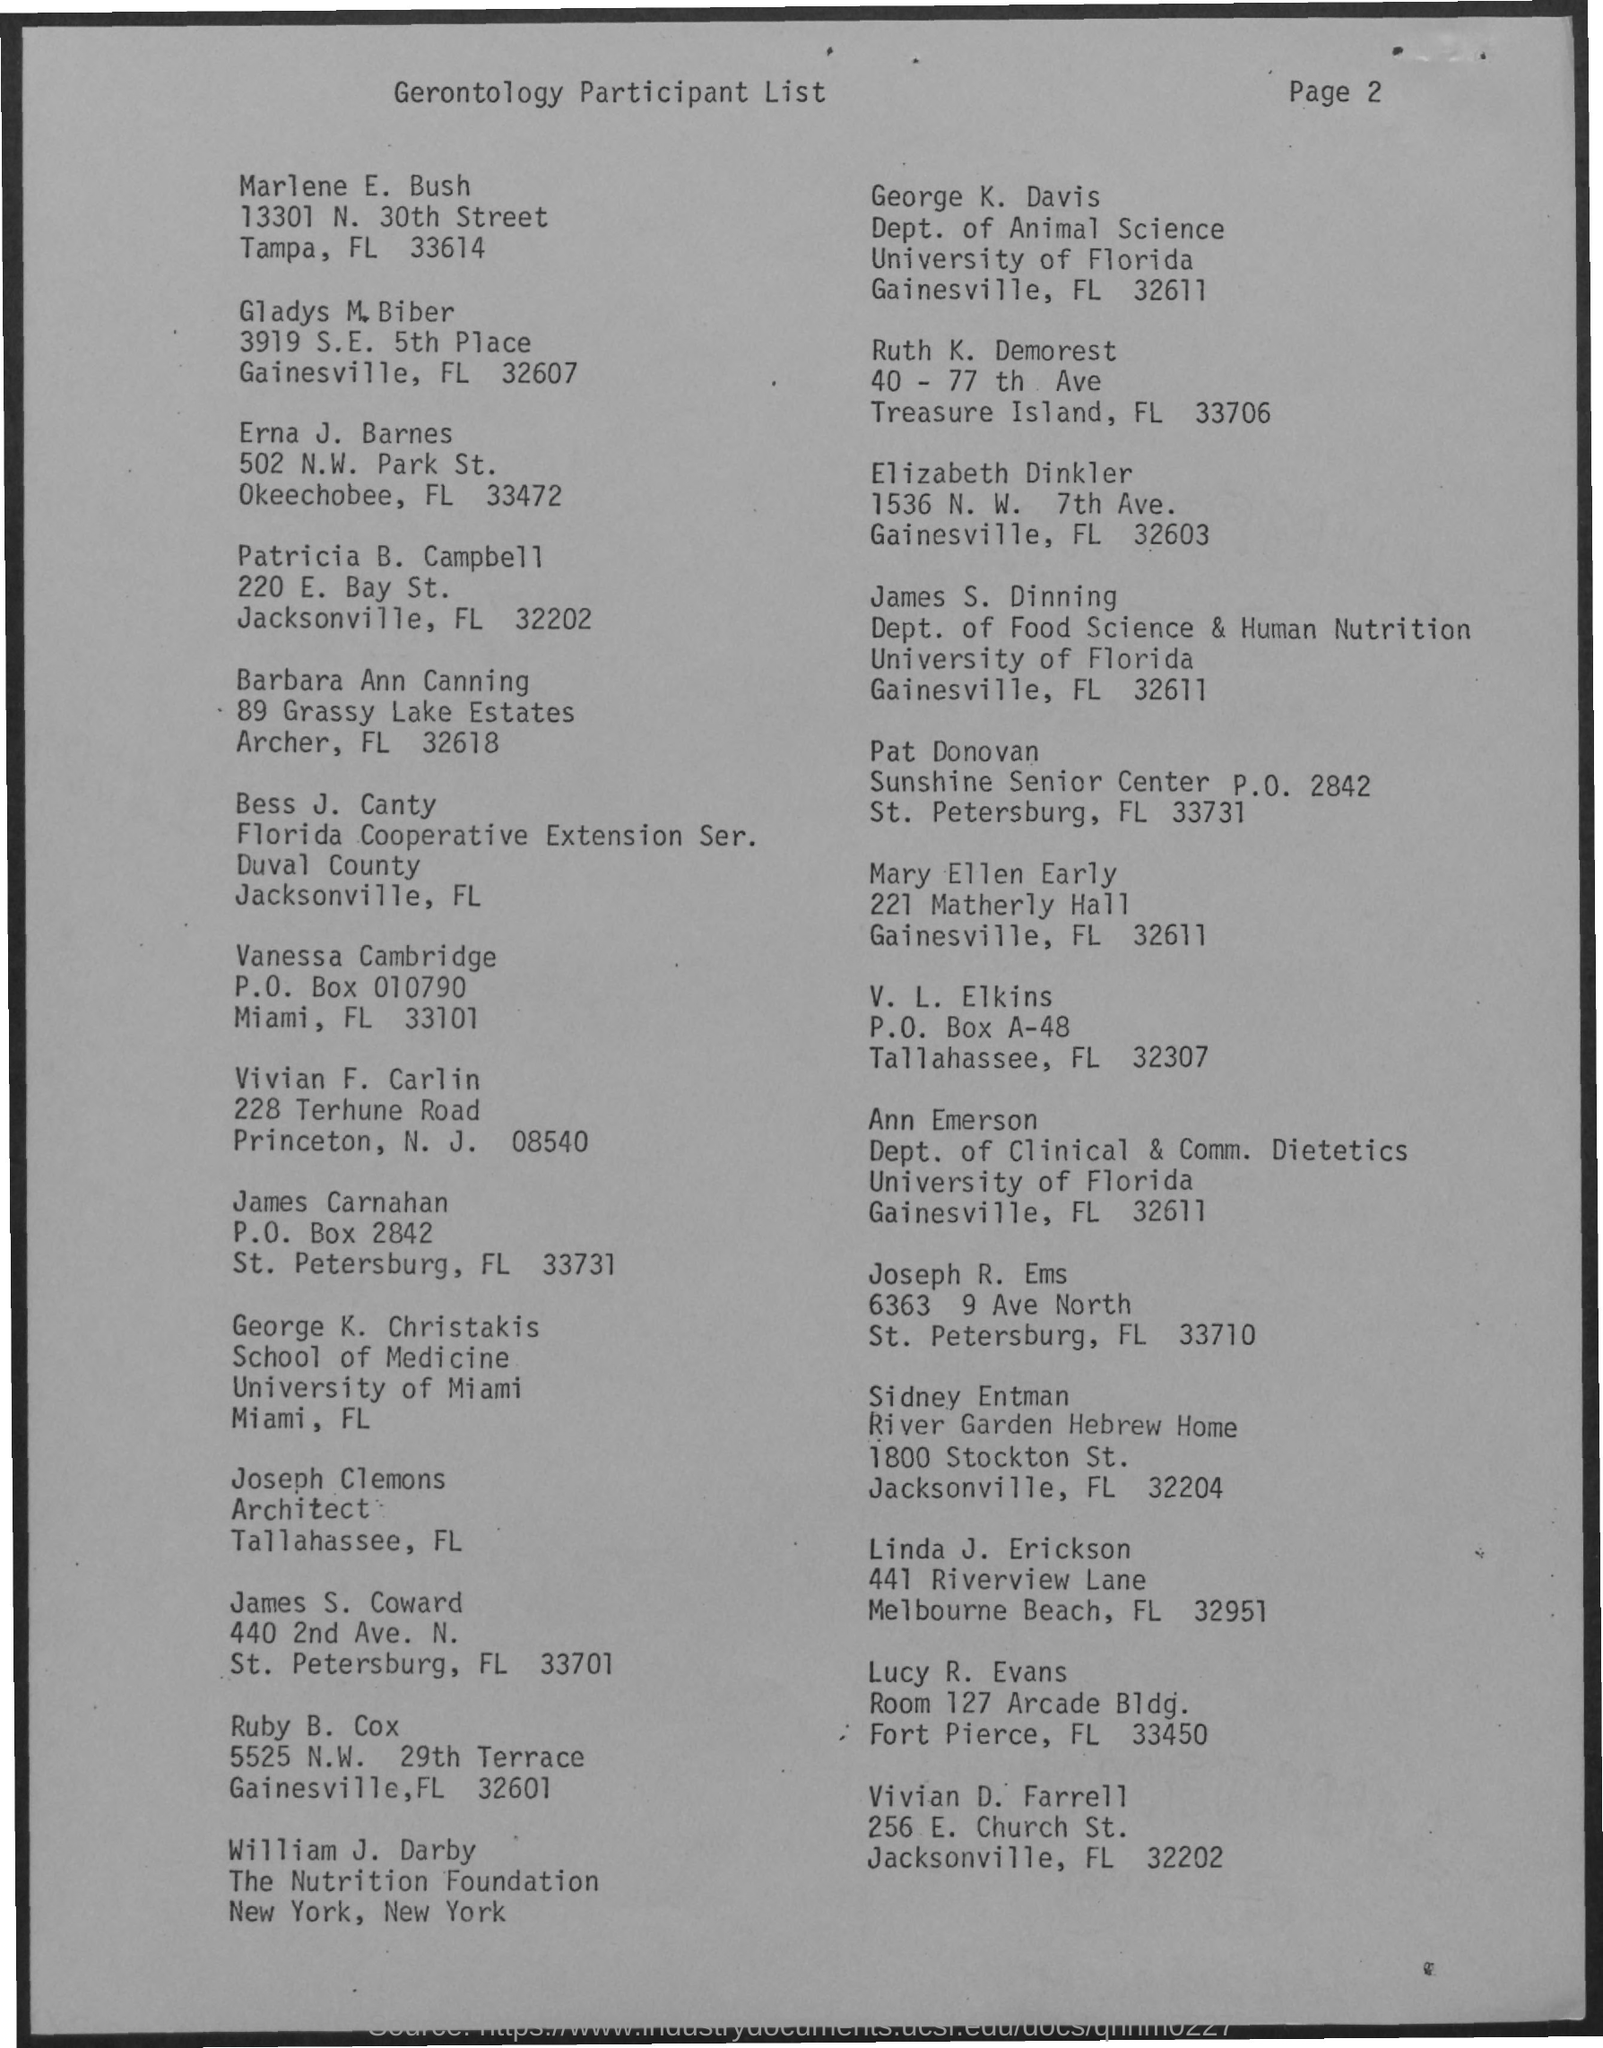Point out several critical features in this image. James S. Dinning is a member of the Department of Food Science & Human Nutrition. George K. Christakis is originally from the University of Miami. The title of the document is Gerontology Participant List. Joseph Clemons holds the designation of architect. 